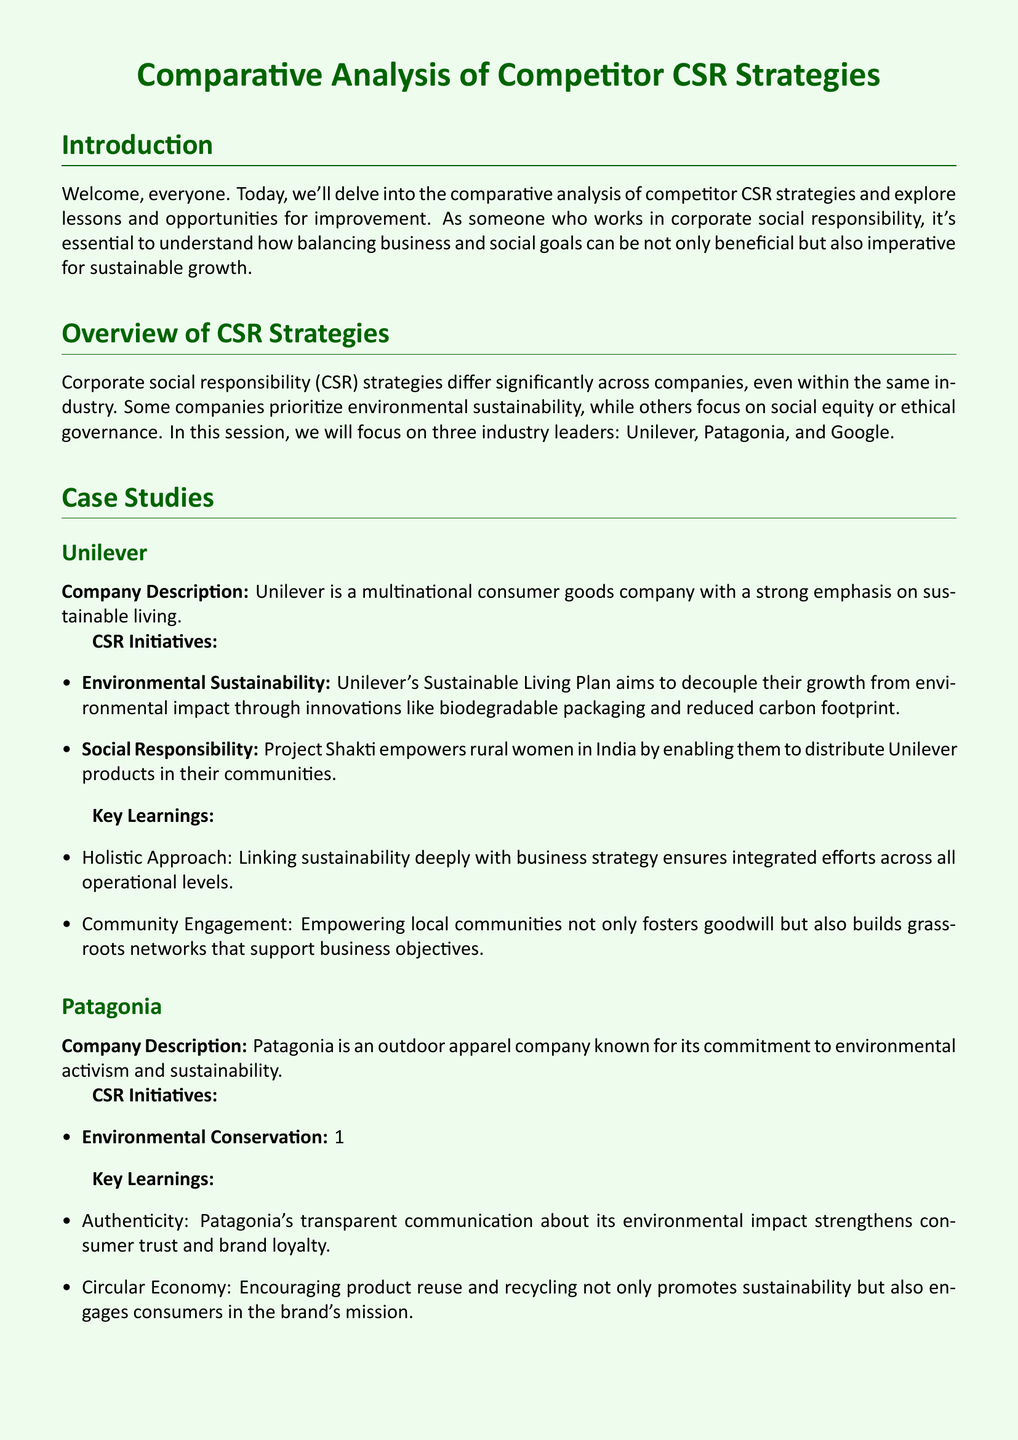What companies are analyzed in the document? The document includes a comparative analysis of three companies: Unilever, Patagonia, and Google.
Answer: Unilever, Patagonia, Google What is Unilever's Sustainable Living Plan aimed at? Unilever's Sustainable Living Plan aims to decouple growth from environmental impact.
Answer: Environmental impact What percentage of sales does Patagonia pledge to environmental causes? Patagonia's 1% for the Planet initiative pledges 1% of sales to environmental causes.
Answer: 1% What is the focus of Google's Grow with Google initiative? The Grow with Google initiative focuses on providing free training and tools for individuals and small businesses.
Answer: Digital economy Which key learning emphasizes community engagement in CSR initiatives? The key learning from Unilever highlights community engagement as critical for building grassroots networks.
Answer: Community Engagement What is one key learning from Patagonia regarding brand trust? Patagonia demonstrates that transparency about environmental impact strengthens consumer trust.
Answer: Authenticity What aspect does Google's CSR strategy integrate with? Google's CSR strategy integrates sustainable energy with its core business expertise.
Answer: Technology How does Unilever's approach towards CSR stand out according to the analysis? Unilever's approach stands out due to its holistic integration with business strategy.
Answer: Holistic Approach 